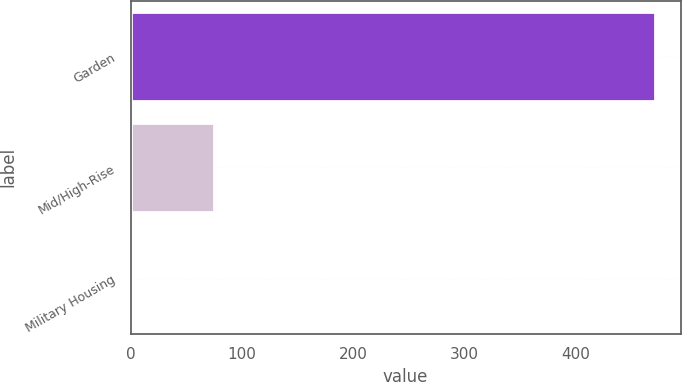Convert chart to OTSL. <chart><loc_0><loc_0><loc_500><loc_500><bar_chart><fcel>Garden<fcel>Mid/High-Rise<fcel>Military Housing<nl><fcel>471<fcel>75<fcel>2<nl></chart> 